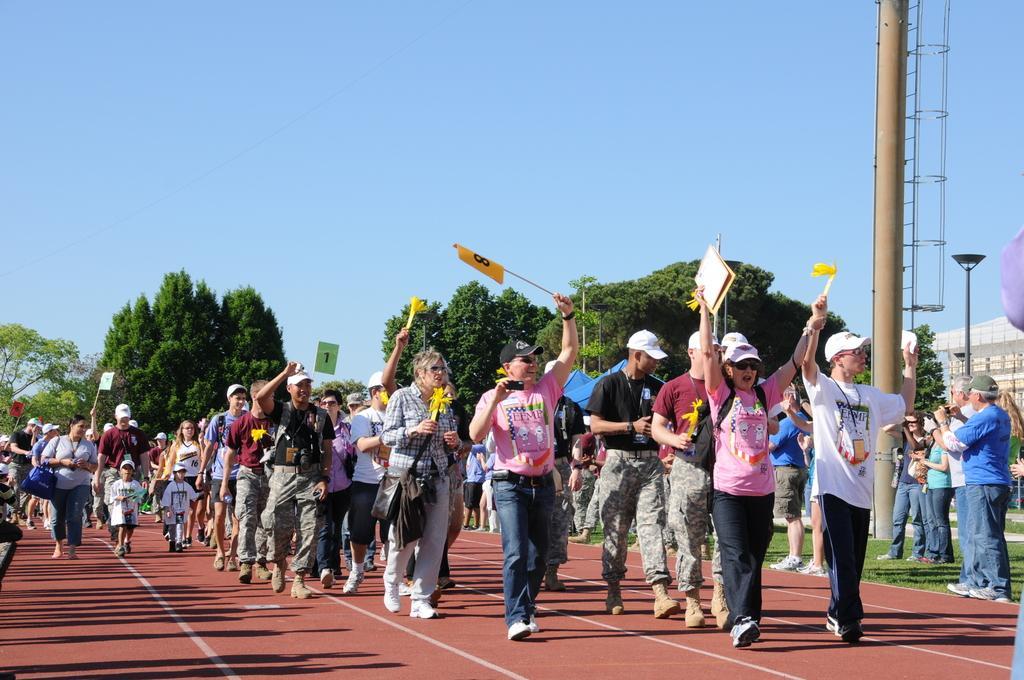Describe this image in one or two sentences. In the center of the image there are people walking holding flags in their hands. In the background of the image there are trees. To the right side of the image there is pole. To the right side bottom of the image there is grass. There are people standing. 